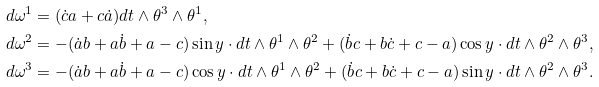Convert formula to latex. <formula><loc_0><loc_0><loc_500><loc_500>d \omega ^ { 1 } & = ( \dot { c } a + c \dot { a } ) d t \wedge \theta ^ { 3 } \wedge \theta ^ { 1 } , \\ d \omega ^ { 2 } & = - ( \dot { a } b + a \dot { b } + a - c ) \sin y \cdot d t \wedge \theta ^ { 1 } \wedge \theta ^ { 2 } + ( \dot { b } c + b \dot { c } + c - a ) \cos y \cdot d t \wedge \theta ^ { 2 } \wedge \theta ^ { 3 } , \\ d \omega ^ { 3 } & = - ( \dot { a } b + a \dot { b } + a - c ) \cos y \cdot d t \wedge \theta ^ { 1 } \wedge \theta ^ { 2 } + ( \dot { b } c + b \dot { c } + c - a ) \sin y \cdot d t \wedge \theta ^ { 2 } \wedge \theta ^ { 3 } .</formula> 